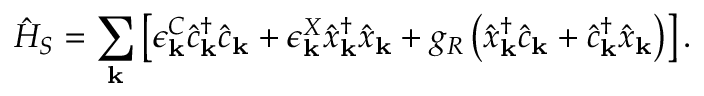Convert formula to latex. <formula><loc_0><loc_0><loc_500><loc_500>\hat { H } _ { S } = \sum _ { k } \left [ \epsilon _ { k } ^ { C } \hat { c } _ { k } ^ { \dagger } \hat { c } _ { k } + \epsilon _ { k } ^ { X } \hat { x } _ { k } ^ { \dagger } \hat { x } _ { k } + g _ { R } \left ( \hat { x } _ { k } ^ { \dagger } \hat { c } _ { k } + \hat { c } _ { k } ^ { \dagger } \hat { x } _ { k } \right ) \right ] .</formula> 